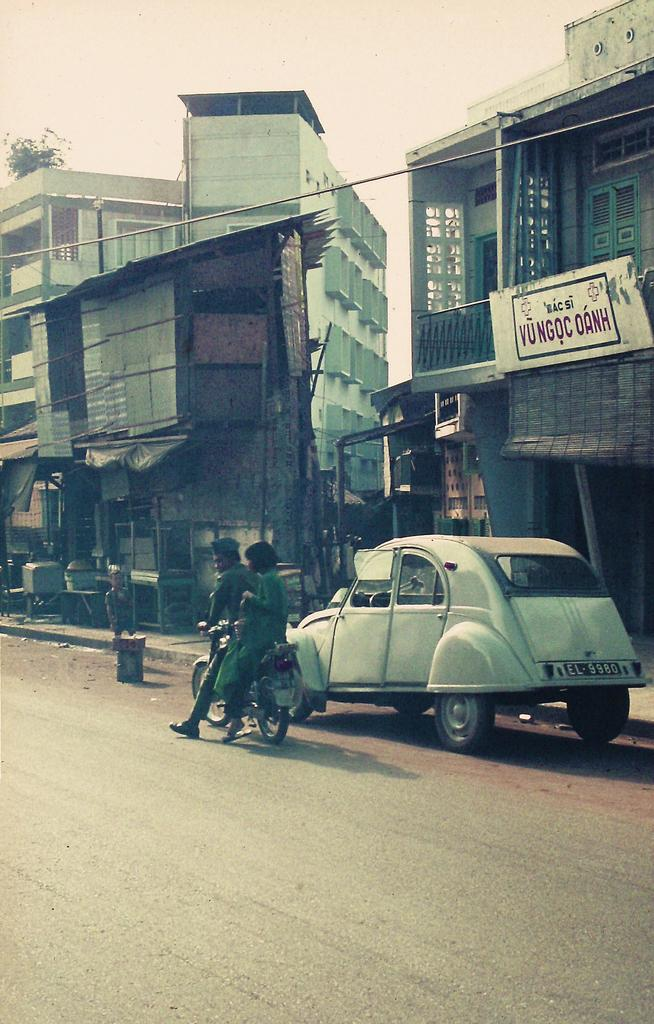What vehicle is located on the right side of the image? There is a car on the right side of the image. What is the man in the image doing? A man is riding a bike in the image. What type of buildings can be seen in the image? There are houses in the image. What is visible at the top of the image? The sky is visible at the top of the image. What line of knowledge is the man in the image studying? There is no indication in the image that the man is studying any specific line of knowledge. What amusement park can be seen in the image? There is no amusement park present in the image. 